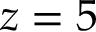Convert formula to latex. <formula><loc_0><loc_0><loc_500><loc_500>z = 5</formula> 